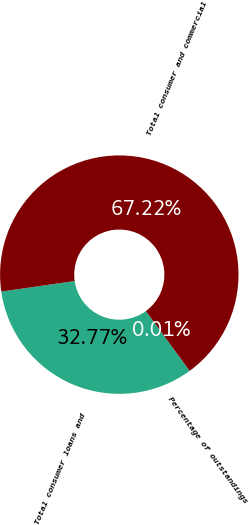<chart> <loc_0><loc_0><loc_500><loc_500><pie_chart><fcel>Total consumer loans and<fcel>Total consumer and commercial<fcel>Percentage of outstandings<nl><fcel>32.77%<fcel>67.22%<fcel>0.01%<nl></chart> 